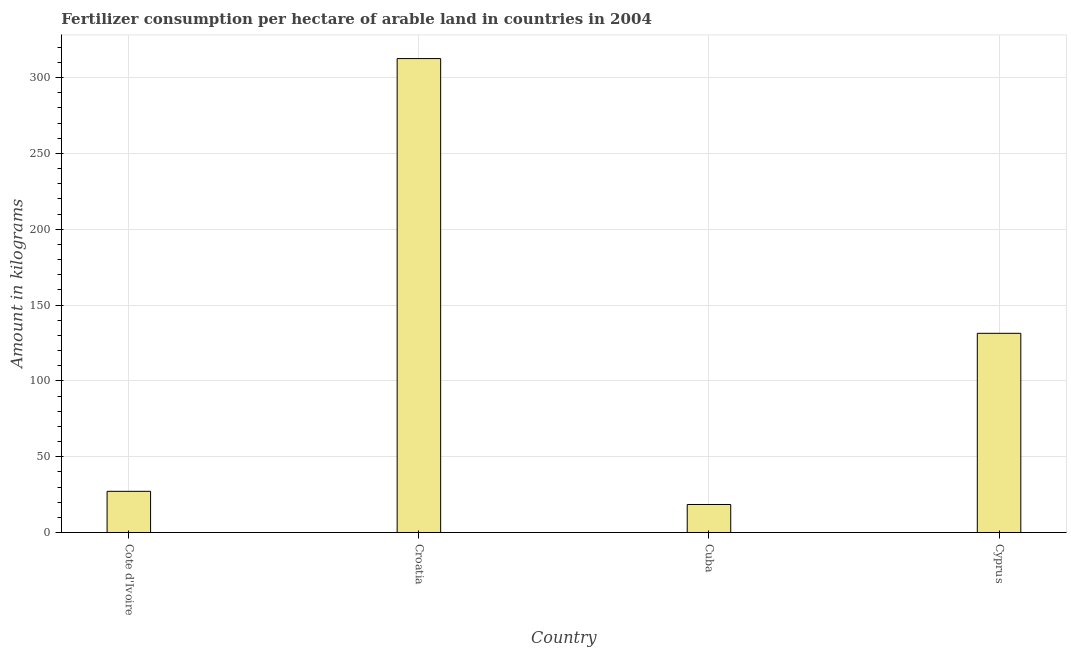Does the graph contain grids?
Offer a terse response. Yes. What is the title of the graph?
Provide a short and direct response. Fertilizer consumption per hectare of arable land in countries in 2004 . What is the label or title of the X-axis?
Ensure brevity in your answer.  Country. What is the label or title of the Y-axis?
Ensure brevity in your answer.  Amount in kilograms. What is the amount of fertilizer consumption in Cyprus?
Make the answer very short. 131.41. Across all countries, what is the maximum amount of fertilizer consumption?
Offer a terse response. 312.58. Across all countries, what is the minimum amount of fertilizer consumption?
Give a very brief answer. 18.53. In which country was the amount of fertilizer consumption maximum?
Keep it short and to the point. Croatia. In which country was the amount of fertilizer consumption minimum?
Provide a succinct answer. Cuba. What is the sum of the amount of fertilizer consumption?
Keep it short and to the point. 489.74. What is the difference between the amount of fertilizer consumption in Cote d'Ivoire and Cuba?
Offer a terse response. 8.69. What is the average amount of fertilizer consumption per country?
Make the answer very short. 122.44. What is the median amount of fertilizer consumption?
Provide a succinct answer. 79.31. What is the ratio of the amount of fertilizer consumption in Croatia to that in Cuba?
Make the answer very short. 16.87. Is the amount of fertilizer consumption in Cuba less than that in Cyprus?
Keep it short and to the point. Yes. What is the difference between the highest and the second highest amount of fertilizer consumption?
Provide a succinct answer. 181.18. What is the difference between the highest and the lowest amount of fertilizer consumption?
Keep it short and to the point. 294.05. Are all the bars in the graph horizontal?
Your answer should be compact. No. How many countries are there in the graph?
Your response must be concise. 4. What is the difference between two consecutive major ticks on the Y-axis?
Make the answer very short. 50. Are the values on the major ticks of Y-axis written in scientific E-notation?
Your response must be concise. No. What is the Amount in kilograms in Cote d'Ivoire?
Provide a succinct answer. 27.22. What is the Amount in kilograms in Croatia?
Provide a succinct answer. 312.58. What is the Amount in kilograms of Cuba?
Ensure brevity in your answer.  18.53. What is the Amount in kilograms of Cyprus?
Keep it short and to the point. 131.41. What is the difference between the Amount in kilograms in Cote d'Ivoire and Croatia?
Keep it short and to the point. -285.37. What is the difference between the Amount in kilograms in Cote d'Ivoire and Cuba?
Your answer should be compact. 8.69. What is the difference between the Amount in kilograms in Cote d'Ivoire and Cyprus?
Your answer should be compact. -104.19. What is the difference between the Amount in kilograms in Croatia and Cuba?
Give a very brief answer. 294.05. What is the difference between the Amount in kilograms in Croatia and Cyprus?
Make the answer very short. 181.18. What is the difference between the Amount in kilograms in Cuba and Cyprus?
Your answer should be very brief. -112.88. What is the ratio of the Amount in kilograms in Cote d'Ivoire to that in Croatia?
Provide a succinct answer. 0.09. What is the ratio of the Amount in kilograms in Cote d'Ivoire to that in Cuba?
Provide a short and direct response. 1.47. What is the ratio of the Amount in kilograms in Cote d'Ivoire to that in Cyprus?
Offer a terse response. 0.21. What is the ratio of the Amount in kilograms in Croatia to that in Cuba?
Your answer should be very brief. 16.87. What is the ratio of the Amount in kilograms in Croatia to that in Cyprus?
Ensure brevity in your answer.  2.38. What is the ratio of the Amount in kilograms in Cuba to that in Cyprus?
Offer a terse response. 0.14. 